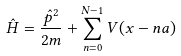Convert formula to latex. <formula><loc_0><loc_0><loc_500><loc_500>\hat { H } = \frac { \hat { p } ^ { 2 } } { 2 m } + \sum _ { n = 0 } ^ { N - 1 } V ( x - n a )</formula> 